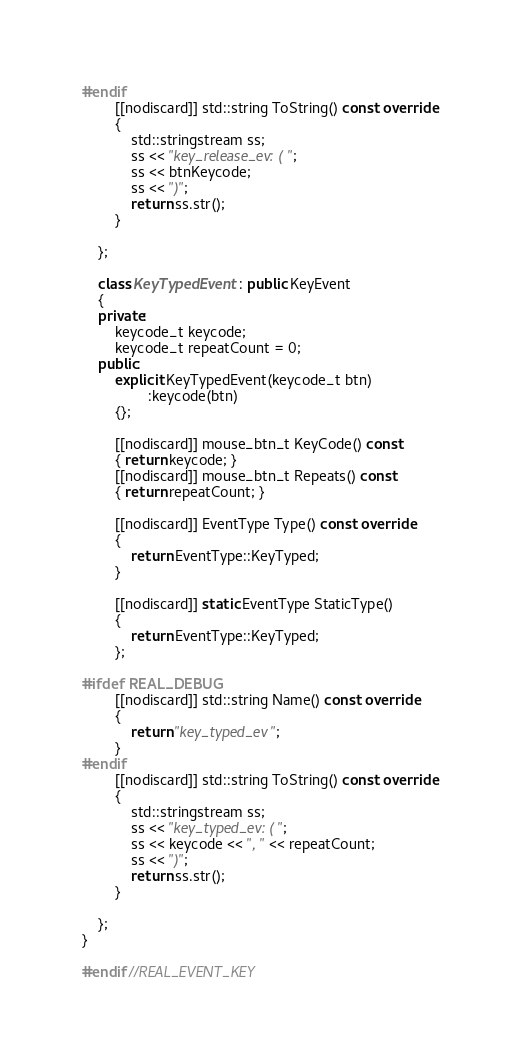Convert code to text. <code><loc_0><loc_0><loc_500><loc_500><_C++_>#endif
		[[nodiscard]] std::string ToString() const override
		{
			std::stringstream ss;
			ss << "key_release_ev: (";
			ss << btnKeycode;
			ss << ")";
			return ss.str();
		}

	};

	class KeyTypedEvent : public KeyEvent
	{
	private:
		keycode_t keycode;
		keycode_t repeatCount = 0;
	public:
		explicit KeyTypedEvent(keycode_t btn)
				:keycode(btn)
		{};

		[[nodiscard]] mouse_btn_t KeyCode() const
		{ return keycode; }
		[[nodiscard]] mouse_btn_t Repeats() const
		{ return repeatCount; }

		[[nodiscard]] EventType Type() const override
		{
			return EventType::KeyTyped;
		}

		[[nodiscard]] static EventType StaticType()
		{
			return EventType::KeyTyped;
		};

#ifdef REAL_DEBUG
		[[nodiscard]] std::string Name() const override
		{
			return "key_typed_ev";
		}
#endif
		[[nodiscard]] std::string ToString() const override
		{
			std::stringstream ss;
			ss << "key_typed_ev: (";
			ss << keycode << ", " << repeatCount;
			ss << ")";
			return ss.str();
		}

	};
}

#endif //REAL_EVENT_KEY
</code> 